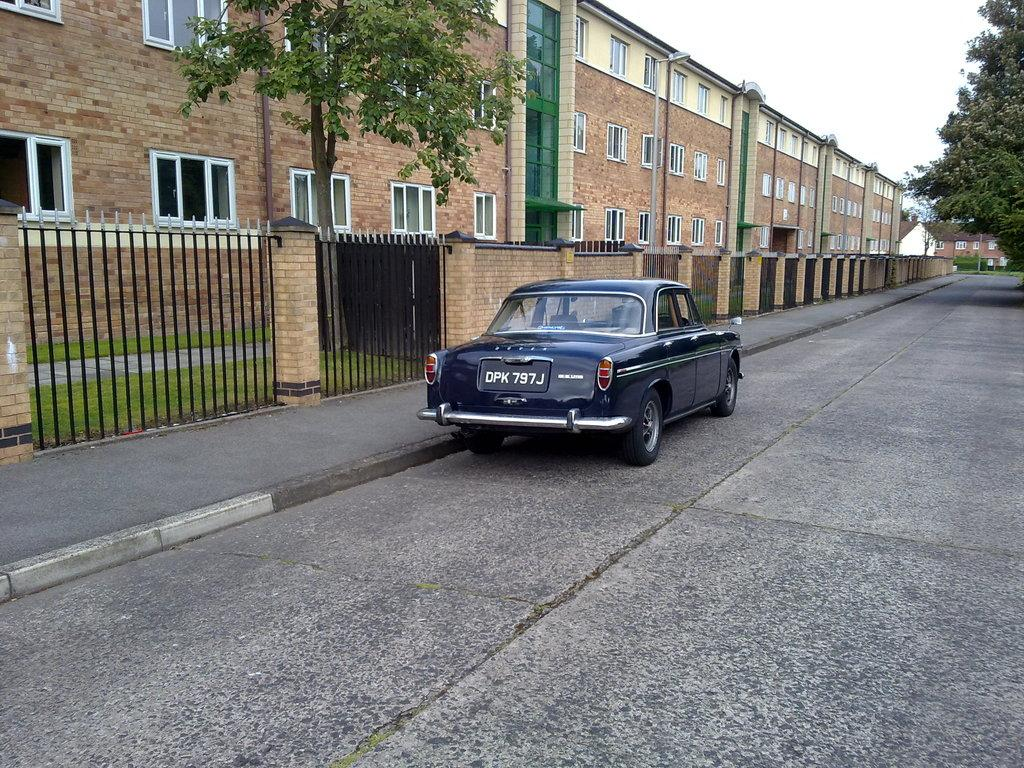What is the main subject of the image? The main subject of the image is a car. What is the car doing in the image? The car is parked in the image. What type of structures can be seen in the image? There are buildings with windows in the image. What is a feature of the buildings in the image? The buildings have glass doors. What type of vegetation is visible in the image? There are trees visible in the image. What type of fencing can be seen in the image? There are iron grilles in the image. What type of pathway is visible in the image? There is a road in the image. What is visible in the sky in the image? The sky is visible in the image. What type of plant is responsible for the car's digestion in the image? There is no plant or digestion process present in the image; it is a parked car. What type of death is depicted in the image? There is no death depicted in the image; it is a scene of a parked car and its surroundings. 